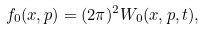Convert formula to latex. <formula><loc_0><loc_0><loc_500><loc_500>f _ { 0 } ( x , p ) = ( 2 \pi ) ^ { 2 } W _ { 0 } ( x , p , t ) ,</formula> 